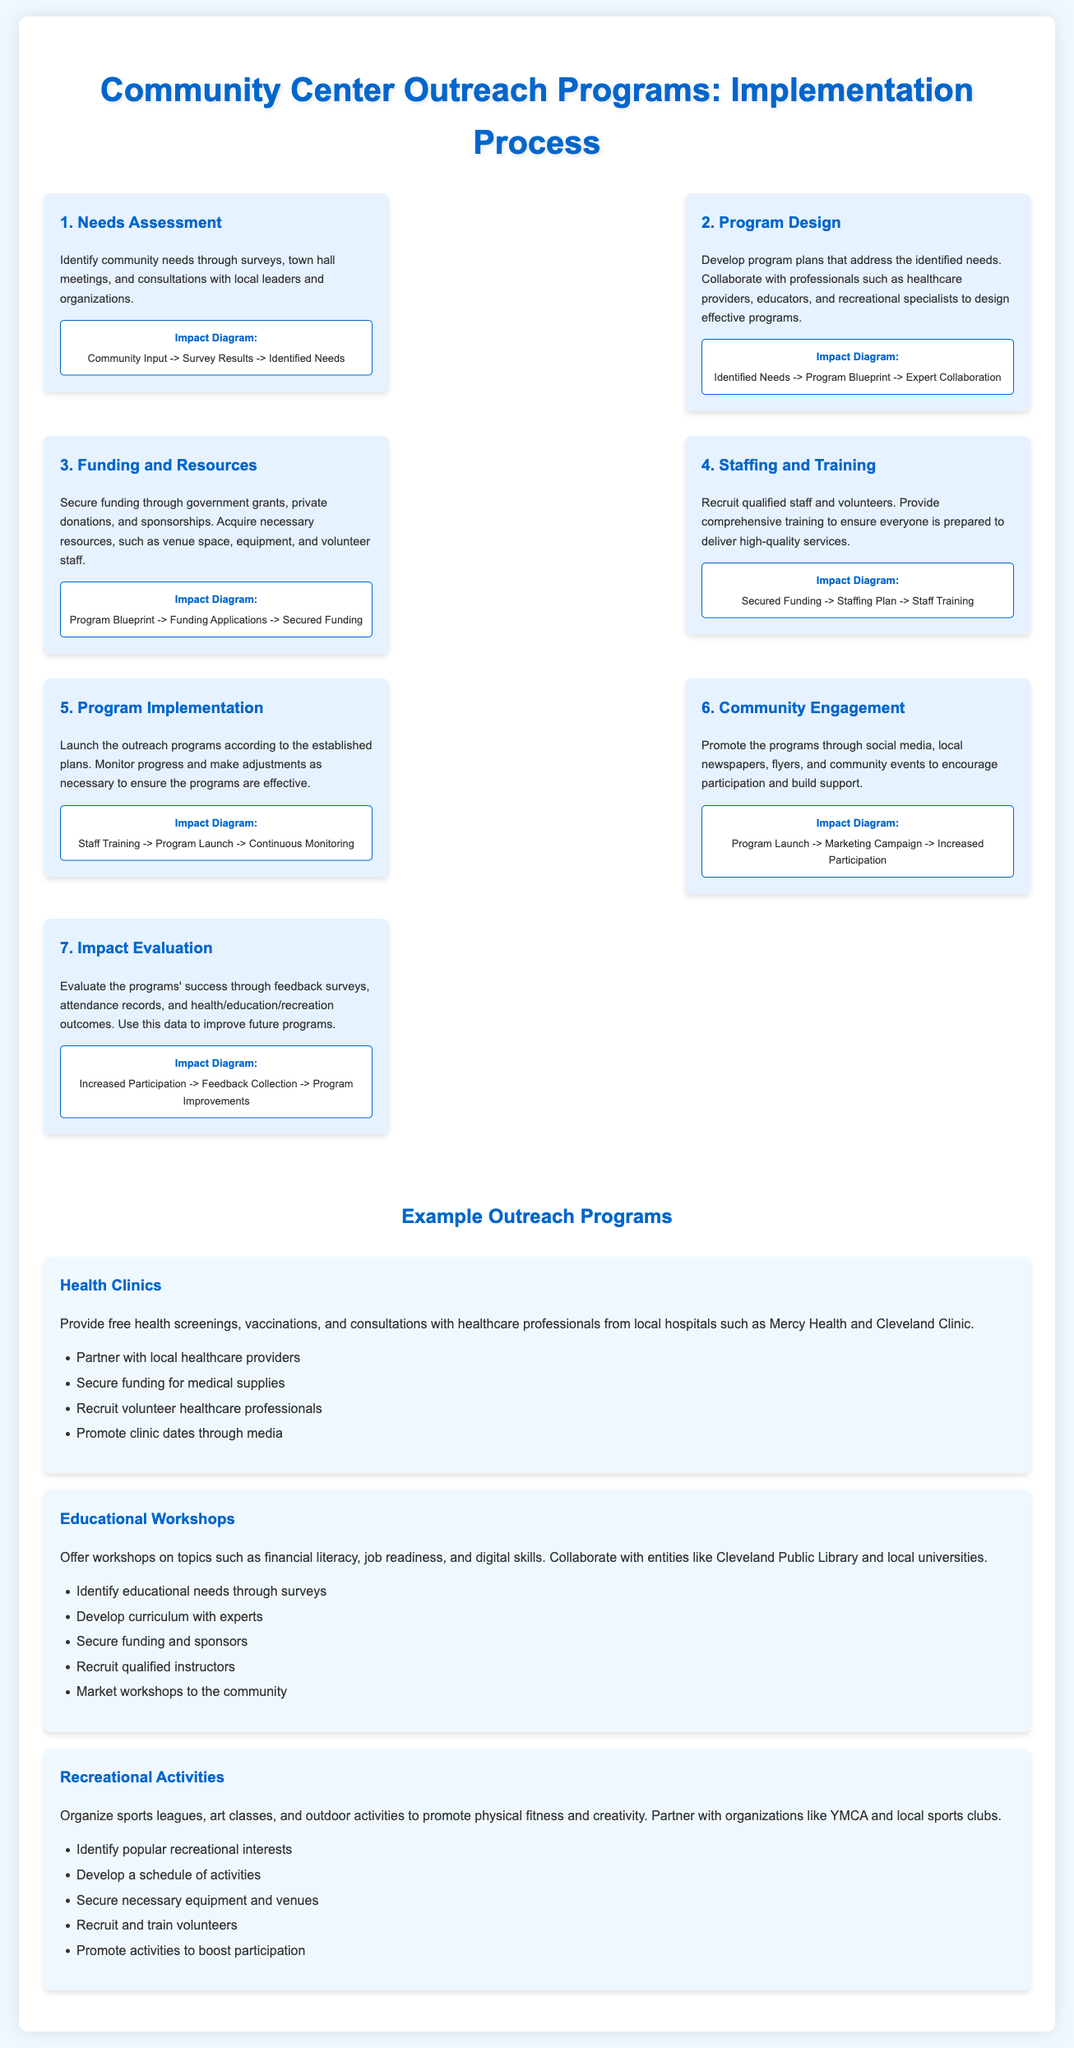what is the first step in the implementation process? The first step in the implementation process is identifying community needs through surveys, town hall meetings, and consultations.
Answer: Needs Assessment which organizations partner with health clinics? The health clinics partner with local healthcare providers such as Mercy Health and Cleveland Clinic.
Answer: Mercy Health and Cleveland Clinic how many outreach program steps are listed in the document? The document outlines a total of seven steps in the implementation process of outreach programs.
Answer: Seven what is the goal of the impact evaluation step? The goal of the impact evaluation step is to evaluate the programs' success through feedback surveys, attendance records, and outcomes.
Answer: Evaluate programs' success which step follows program design? The step that follows program design is funding and resources.
Answer: Funding and Resources what method is suggested to promote community engagement? The document suggests promoting the programs through social media, local newspapers, flyers, and community events.
Answer: Social media, local newspapers, flyers, and community events which program focuses on financial literacy? The program that focuses on financial literacy is the educational workshops.
Answer: Educational Workshops how should the community be engaged after program implementation? Community engagement should be encouraged through a marketing campaign to increase participation.
Answer: Marketing Campaign 